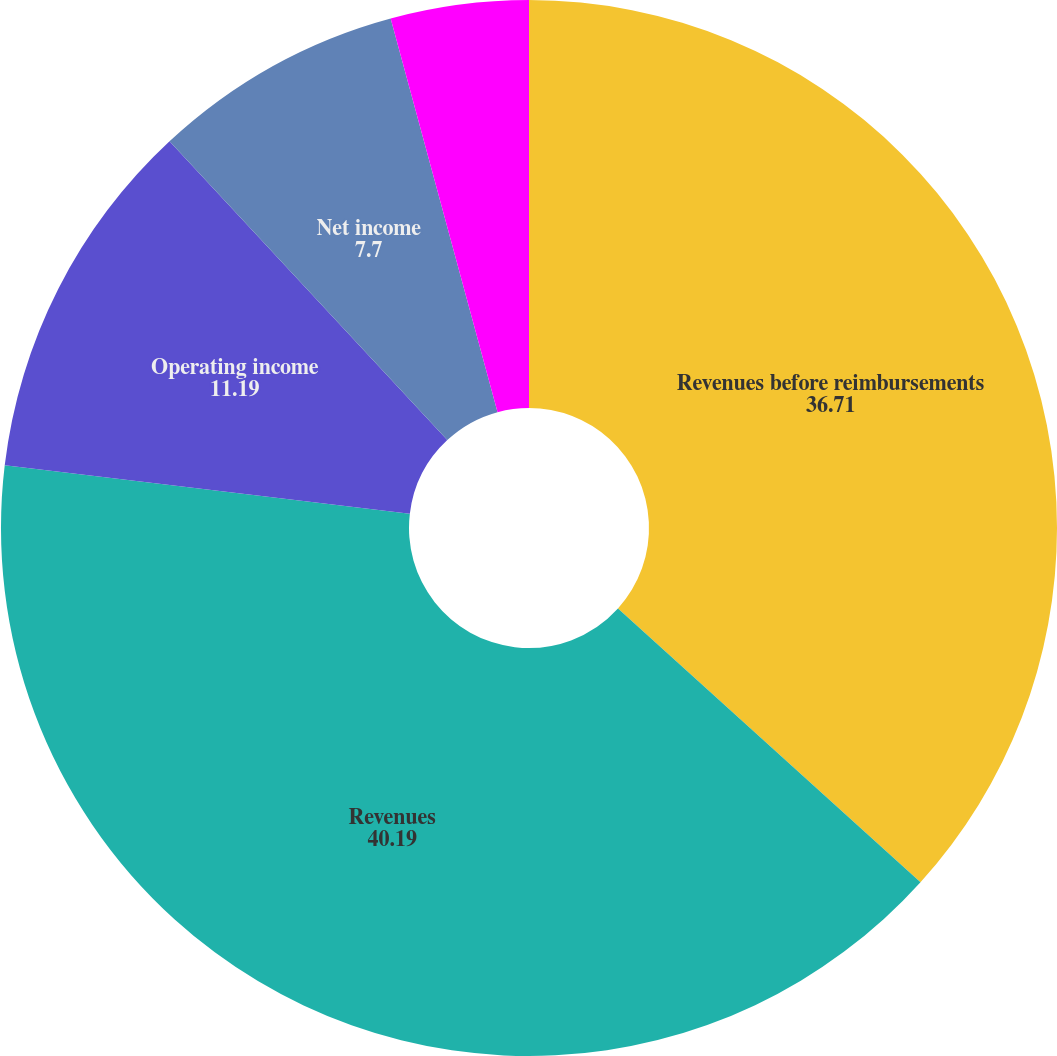<chart> <loc_0><loc_0><loc_500><loc_500><pie_chart><fcel>Revenues before reimbursements<fcel>Revenues<fcel>Operating income<fcel>Net income<fcel>Net income attributable to<nl><fcel>36.71%<fcel>40.19%<fcel>11.19%<fcel>7.7%<fcel>4.22%<nl></chart> 